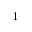<formula> <loc_0><loc_0><loc_500><loc_500>^ { - 1 }</formula> 